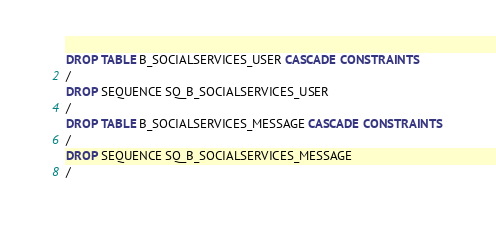<code> <loc_0><loc_0><loc_500><loc_500><_SQL_>DROP TABLE B_SOCIALSERVICES_USER CASCADE CONSTRAINTS
/
DROP SEQUENCE SQ_B_SOCIALSERVICES_USER
/
DROP TABLE B_SOCIALSERVICES_MESSAGE CASCADE CONSTRAINTS
/
DROP SEQUENCE SQ_B_SOCIALSERVICES_MESSAGE
/</code> 